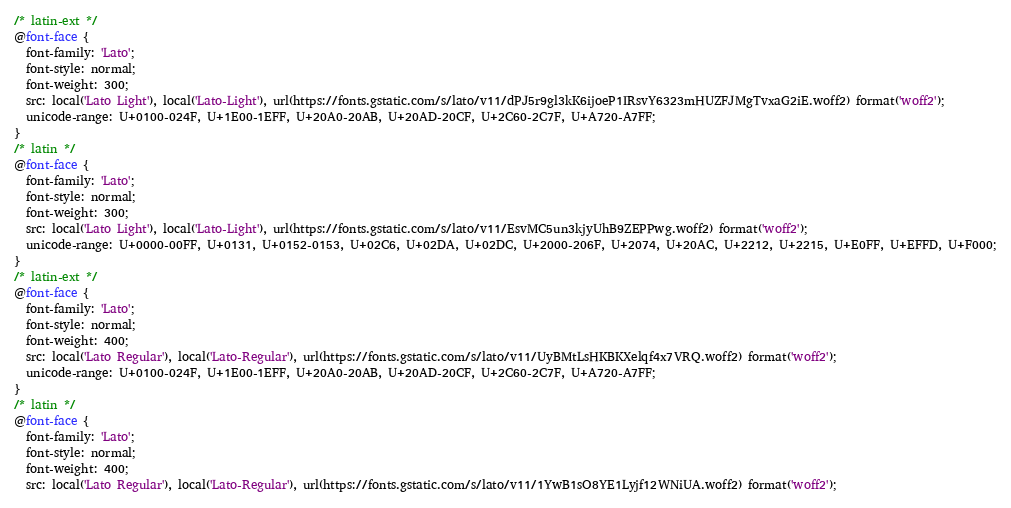Convert code to text. <code><loc_0><loc_0><loc_500><loc_500><_CSS_>/* latin-ext */
@font-face {
  font-family: 'Lato';
  font-style: normal;
  font-weight: 300;
  src: local('Lato Light'), local('Lato-Light'), url(https://fonts.gstatic.com/s/lato/v11/dPJ5r9gl3kK6ijoeP1IRsvY6323mHUZFJMgTvxaG2iE.woff2) format('woff2');
  unicode-range: U+0100-024F, U+1E00-1EFF, U+20A0-20AB, U+20AD-20CF, U+2C60-2C7F, U+A720-A7FF;
}
/* latin */
@font-face {
  font-family: 'Lato';
  font-style: normal;
  font-weight: 300;
  src: local('Lato Light'), local('Lato-Light'), url(https://fonts.gstatic.com/s/lato/v11/EsvMC5un3kjyUhB9ZEPPwg.woff2) format('woff2');
  unicode-range: U+0000-00FF, U+0131, U+0152-0153, U+02C6, U+02DA, U+02DC, U+2000-206F, U+2074, U+20AC, U+2212, U+2215, U+E0FF, U+EFFD, U+F000;
}
/* latin-ext */
@font-face {
  font-family: 'Lato';
  font-style: normal;
  font-weight: 400;
  src: local('Lato Regular'), local('Lato-Regular'), url(https://fonts.gstatic.com/s/lato/v11/UyBMtLsHKBKXelqf4x7VRQ.woff2) format('woff2');
  unicode-range: U+0100-024F, U+1E00-1EFF, U+20A0-20AB, U+20AD-20CF, U+2C60-2C7F, U+A720-A7FF;
}
/* latin */
@font-face {
  font-family: 'Lato';
  font-style: normal;
  font-weight: 400;
  src: local('Lato Regular'), local('Lato-Regular'), url(https://fonts.gstatic.com/s/lato/v11/1YwB1sO8YE1Lyjf12WNiUA.woff2) format('woff2');</code> 